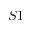<formula> <loc_0><loc_0><loc_500><loc_500>S 1</formula> 